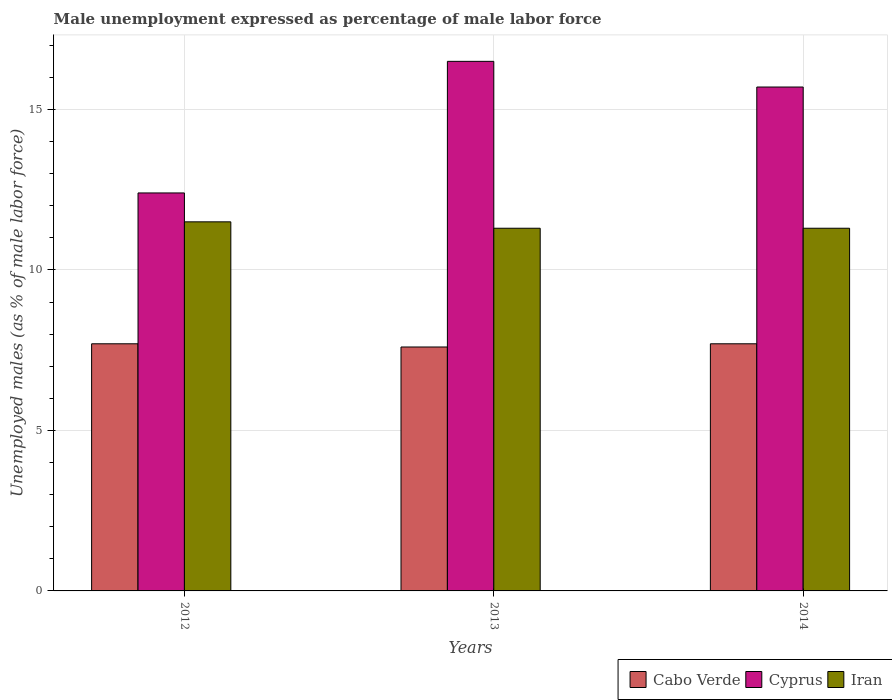How many different coloured bars are there?
Provide a short and direct response. 3. Are the number of bars per tick equal to the number of legend labels?
Provide a short and direct response. Yes. Are the number of bars on each tick of the X-axis equal?
Your response must be concise. Yes. What is the label of the 1st group of bars from the left?
Give a very brief answer. 2012. In how many cases, is the number of bars for a given year not equal to the number of legend labels?
Your answer should be compact. 0. What is the unemployment in males in in Cabo Verde in 2014?
Ensure brevity in your answer.  7.7. Across all years, what is the minimum unemployment in males in in Iran?
Provide a succinct answer. 11.3. In which year was the unemployment in males in in Iran maximum?
Provide a succinct answer. 2012. In which year was the unemployment in males in in Cyprus minimum?
Provide a short and direct response. 2012. What is the total unemployment in males in in Iran in the graph?
Offer a very short reply. 34.1. What is the difference between the unemployment in males in in Cabo Verde in 2013 and that in 2014?
Give a very brief answer. -0.1. What is the difference between the unemployment in males in in Cabo Verde in 2012 and the unemployment in males in in Iran in 2013?
Provide a succinct answer. -3.6. What is the average unemployment in males in in Cyprus per year?
Provide a short and direct response. 14.87. In the year 2014, what is the difference between the unemployment in males in in Cyprus and unemployment in males in in Iran?
Ensure brevity in your answer.  4.4. In how many years, is the unemployment in males in in Cabo Verde greater than 10 %?
Give a very brief answer. 0. What is the ratio of the unemployment in males in in Iran in 2012 to that in 2014?
Keep it short and to the point. 1.02. Is the unemployment in males in in Iran in 2013 less than that in 2014?
Provide a short and direct response. No. Is the difference between the unemployment in males in in Cyprus in 2013 and 2014 greater than the difference between the unemployment in males in in Iran in 2013 and 2014?
Your response must be concise. Yes. What is the difference between the highest and the second highest unemployment in males in in Iran?
Offer a very short reply. 0.2. What is the difference between the highest and the lowest unemployment in males in in Cabo Verde?
Keep it short and to the point. 0.1. In how many years, is the unemployment in males in in Cyprus greater than the average unemployment in males in in Cyprus taken over all years?
Give a very brief answer. 2. Is the sum of the unemployment in males in in Cabo Verde in 2013 and 2014 greater than the maximum unemployment in males in in Cyprus across all years?
Your response must be concise. No. What does the 1st bar from the left in 2012 represents?
Make the answer very short. Cabo Verde. What does the 1st bar from the right in 2013 represents?
Offer a terse response. Iran. Is it the case that in every year, the sum of the unemployment in males in in Cabo Verde and unemployment in males in in Cyprus is greater than the unemployment in males in in Iran?
Offer a terse response. Yes. Are all the bars in the graph horizontal?
Your answer should be very brief. No. Are the values on the major ticks of Y-axis written in scientific E-notation?
Ensure brevity in your answer.  No. What is the title of the graph?
Your answer should be compact. Male unemployment expressed as percentage of male labor force. What is the label or title of the Y-axis?
Offer a terse response. Unemployed males (as % of male labor force). What is the Unemployed males (as % of male labor force) in Cabo Verde in 2012?
Your answer should be compact. 7.7. What is the Unemployed males (as % of male labor force) of Cyprus in 2012?
Your response must be concise. 12.4. What is the Unemployed males (as % of male labor force) of Cabo Verde in 2013?
Provide a succinct answer. 7.6. What is the Unemployed males (as % of male labor force) in Cyprus in 2013?
Offer a terse response. 16.5. What is the Unemployed males (as % of male labor force) in Iran in 2013?
Keep it short and to the point. 11.3. What is the Unemployed males (as % of male labor force) of Cabo Verde in 2014?
Make the answer very short. 7.7. What is the Unemployed males (as % of male labor force) of Cyprus in 2014?
Your response must be concise. 15.7. What is the Unemployed males (as % of male labor force) of Iran in 2014?
Keep it short and to the point. 11.3. Across all years, what is the maximum Unemployed males (as % of male labor force) of Cabo Verde?
Your answer should be compact. 7.7. Across all years, what is the maximum Unemployed males (as % of male labor force) of Cyprus?
Your response must be concise. 16.5. Across all years, what is the maximum Unemployed males (as % of male labor force) of Iran?
Provide a succinct answer. 11.5. Across all years, what is the minimum Unemployed males (as % of male labor force) in Cabo Verde?
Ensure brevity in your answer.  7.6. Across all years, what is the minimum Unemployed males (as % of male labor force) in Cyprus?
Your answer should be very brief. 12.4. Across all years, what is the minimum Unemployed males (as % of male labor force) in Iran?
Your response must be concise. 11.3. What is the total Unemployed males (as % of male labor force) of Cyprus in the graph?
Your response must be concise. 44.6. What is the total Unemployed males (as % of male labor force) of Iran in the graph?
Provide a succinct answer. 34.1. What is the difference between the Unemployed males (as % of male labor force) in Cabo Verde in 2012 and that in 2013?
Give a very brief answer. 0.1. What is the difference between the Unemployed males (as % of male labor force) of Iran in 2012 and that in 2013?
Your response must be concise. 0.2. What is the difference between the Unemployed males (as % of male labor force) in Iran in 2012 and that in 2014?
Your response must be concise. 0.2. What is the difference between the Unemployed males (as % of male labor force) in Cabo Verde in 2013 and that in 2014?
Offer a terse response. -0.1. What is the difference between the Unemployed males (as % of male labor force) in Iran in 2013 and that in 2014?
Offer a very short reply. 0. What is the difference between the Unemployed males (as % of male labor force) of Cabo Verde in 2012 and the Unemployed males (as % of male labor force) of Iran in 2014?
Keep it short and to the point. -3.6. What is the difference between the Unemployed males (as % of male labor force) in Cabo Verde in 2013 and the Unemployed males (as % of male labor force) in Cyprus in 2014?
Your response must be concise. -8.1. What is the difference between the Unemployed males (as % of male labor force) of Cabo Verde in 2013 and the Unemployed males (as % of male labor force) of Iran in 2014?
Keep it short and to the point. -3.7. What is the difference between the Unemployed males (as % of male labor force) of Cyprus in 2013 and the Unemployed males (as % of male labor force) of Iran in 2014?
Make the answer very short. 5.2. What is the average Unemployed males (as % of male labor force) of Cabo Verde per year?
Provide a short and direct response. 7.67. What is the average Unemployed males (as % of male labor force) in Cyprus per year?
Keep it short and to the point. 14.87. What is the average Unemployed males (as % of male labor force) in Iran per year?
Make the answer very short. 11.37. In the year 2012, what is the difference between the Unemployed males (as % of male labor force) of Cabo Verde and Unemployed males (as % of male labor force) of Iran?
Provide a succinct answer. -3.8. In the year 2012, what is the difference between the Unemployed males (as % of male labor force) of Cyprus and Unemployed males (as % of male labor force) of Iran?
Give a very brief answer. 0.9. In the year 2013, what is the difference between the Unemployed males (as % of male labor force) of Cabo Verde and Unemployed males (as % of male labor force) of Cyprus?
Provide a short and direct response. -8.9. In the year 2013, what is the difference between the Unemployed males (as % of male labor force) of Cabo Verde and Unemployed males (as % of male labor force) of Iran?
Offer a terse response. -3.7. In the year 2013, what is the difference between the Unemployed males (as % of male labor force) in Cyprus and Unemployed males (as % of male labor force) in Iran?
Ensure brevity in your answer.  5.2. In the year 2014, what is the difference between the Unemployed males (as % of male labor force) in Cabo Verde and Unemployed males (as % of male labor force) in Iran?
Ensure brevity in your answer.  -3.6. What is the ratio of the Unemployed males (as % of male labor force) of Cabo Verde in 2012 to that in 2013?
Your answer should be compact. 1.01. What is the ratio of the Unemployed males (as % of male labor force) in Cyprus in 2012 to that in 2013?
Ensure brevity in your answer.  0.75. What is the ratio of the Unemployed males (as % of male labor force) of Iran in 2012 to that in 2013?
Your answer should be compact. 1.02. What is the ratio of the Unemployed males (as % of male labor force) in Cyprus in 2012 to that in 2014?
Provide a short and direct response. 0.79. What is the ratio of the Unemployed males (as % of male labor force) of Iran in 2012 to that in 2014?
Provide a succinct answer. 1.02. What is the ratio of the Unemployed males (as % of male labor force) of Cabo Verde in 2013 to that in 2014?
Make the answer very short. 0.99. What is the ratio of the Unemployed males (as % of male labor force) in Cyprus in 2013 to that in 2014?
Provide a short and direct response. 1.05. What is the ratio of the Unemployed males (as % of male labor force) in Iran in 2013 to that in 2014?
Provide a short and direct response. 1. What is the difference between the highest and the second highest Unemployed males (as % of male labor force) in Cabo Verde?
Give a very brief answer. 0. What is the difference between the highest and the second highest Unemployed males (as % of male labor force) of Iran?
Provide a succinct answer. 0.2. What is the difference between the highest and the lowest Unemployed males (as % of male labor force) in Cabo Verde?
Keep it short and to the point. 0.1. What is the difference between the highest and the lowest Unemployed males (as % of male labor force) in Cyprus?
Your answer should be very brief. 4.1. What is the difference between the highest and the lowest Unemployed males (as % of male labor force) of Iran?
Offer a very short reply. 0.2. 